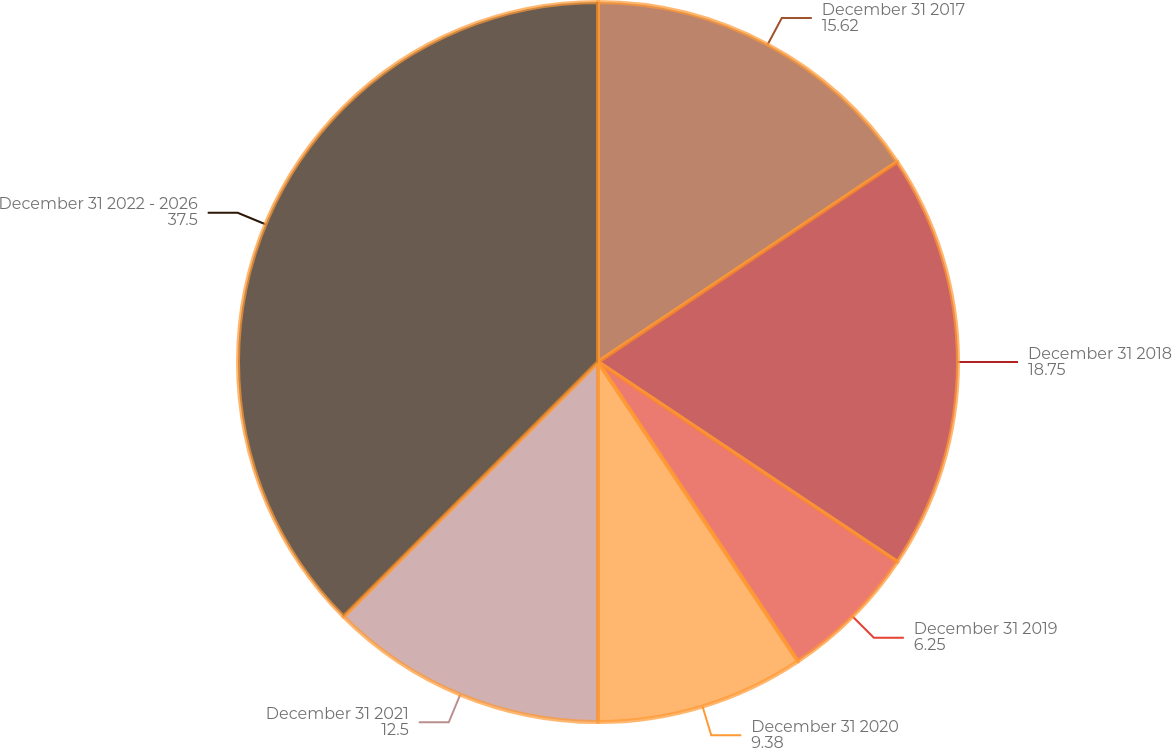Convert chart to OTSL. <chart><loc_0><loc_0><loc_500><loc_500><pie_chart><fcel>December 31 2017<fcel>December 31 2018<fcel>December 31 2019<fcel>December 31 2020<fcel>December 31 2021<fcel>December 31 2022 - 2026<nl><fcel>15.62%<fcel>18.75%<fcel>6.25%<fcel>9.38%<fcel>12.5%<fcel>37.5%<nl></chart> 